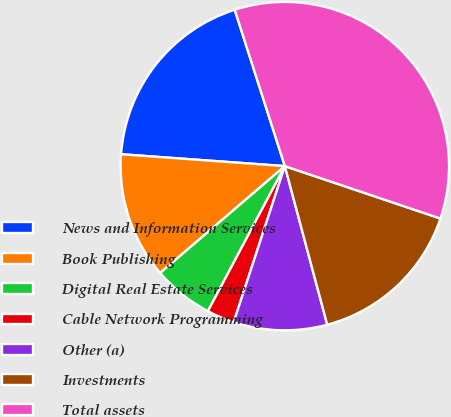Convert chart to OTSL. <chart><loc_0><loc_0><loc_500><loc_500><pie_chart><fcel>News and Information Services<fcel>Book Publishing<fcel>Digital Real Estate Services<fcel>Cable Network Programming<fcel>Other (a)<fcel>Investments<fcel>Total assets<nl><fcel>18.91%<fcel>12.43%<fcel>5.96%<fcel>2.72%<fcel>9.2%<fcel>15.67%<fcel>35.11%<nl></chart> 